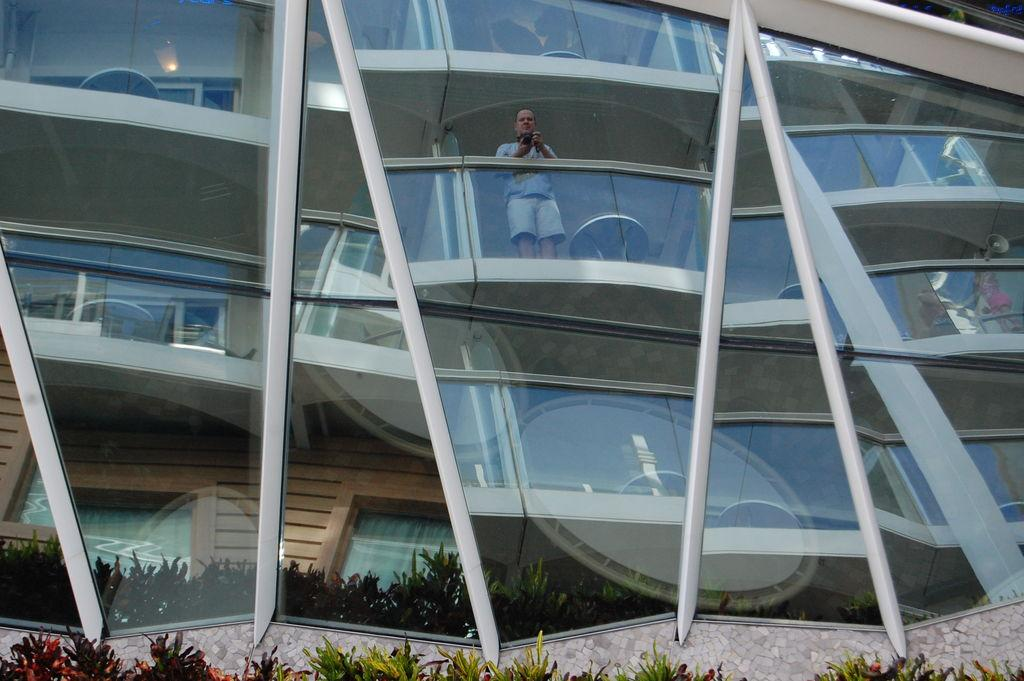What type of building can be seen in the image? There is a building made of glass in the image. Can you describe the person in the image? A man is standing in the image, and he is wearing clothes. What else can be seen in the image besides the building and the man? There are plants visible in the image. How can you tell that there is light in the image? The presence of light is indicated by the visibility of the man, building, and plants. Is there a river flowing through the building in the image? No, there is no river visible in the image. What type of health benefits can be gained from the building in the image? The image does not provide any information about health benefits associated with the building. 